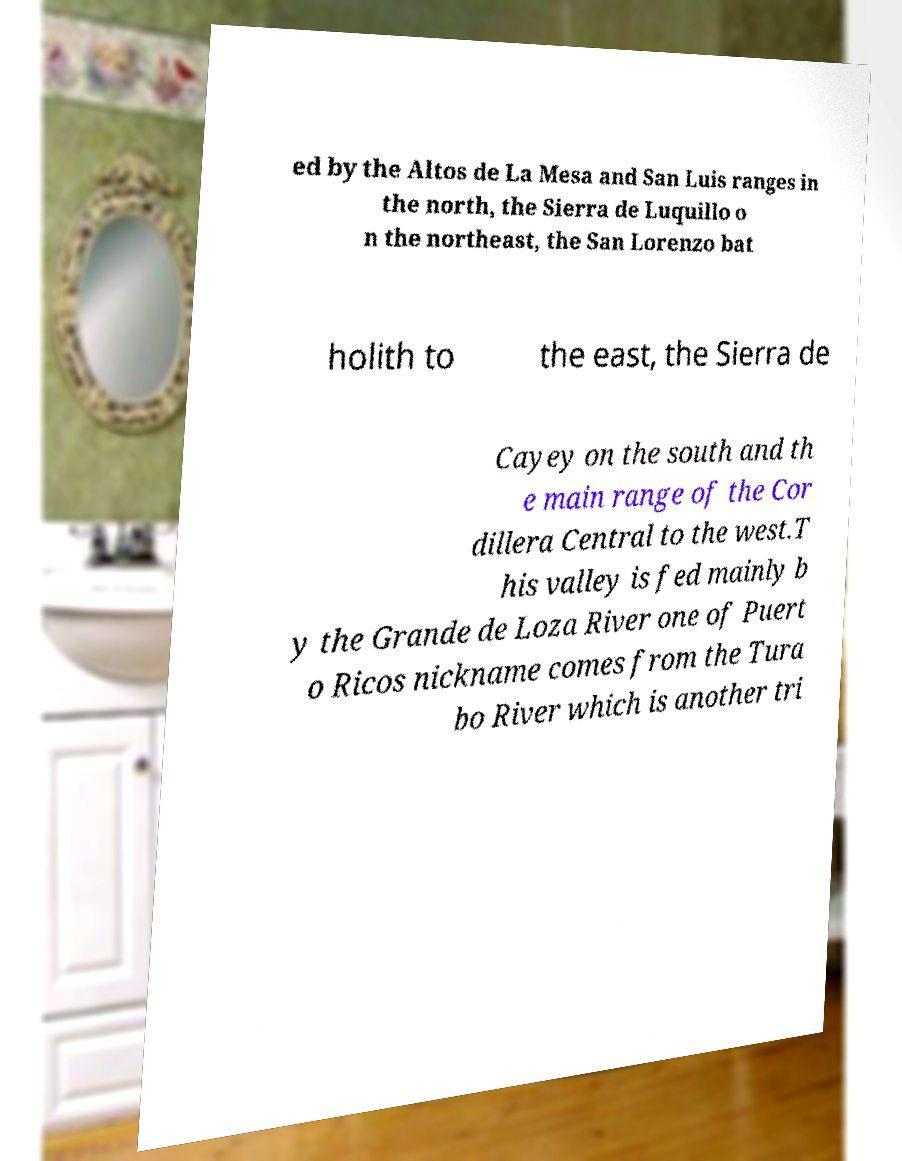Please read and relay the text visible in this image. What does it say? ed by the Altos de La Mesa and San Luis ranges in the north, the Sierra de Luquillo o n the northeast, the San Lorenzo bat holith to the east, the Sierra de Cayey on the south and th e main range of the Cor dillera Central to the west.T his valley is fed mainly b y the Grande de Loza River one of Puert o Ricos nickname comes from the Tura bo River which is another tri 